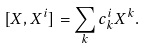Convert formula to latex. <formula><loc_0><loc_0><loc_500><loc_500>[ X , X ^ { i } ] = \sum _ { k } c ^ { i } _ { k } X ^ { k } .</formula> 